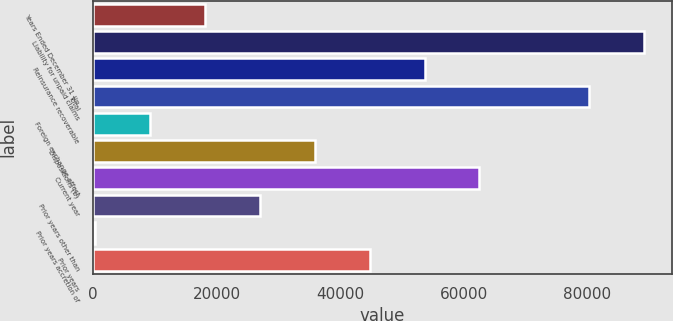<chart> <loc_0><loc_0><loc_500><loc_500><bar_chart><fcel>Years Ended December 31 (in<fcel>Liability for unpaid claims<fcel>Reinsurance recoverable<fcel>Total<fcel>Foreign exchange effect<fcel>Dispositions (b)<fcel>Current year<fcel>Prior years other than<fcel>Prior years accretion of<fcel>Prior years<nl><fcel>18102<fcel>89258<fcel>53680<fcel>80363.5<fcel>9207.5<fcel>35891<fcel>62574.5<fcel>26996.5<fcel>313<fcel>44785.5<nl></chart> 